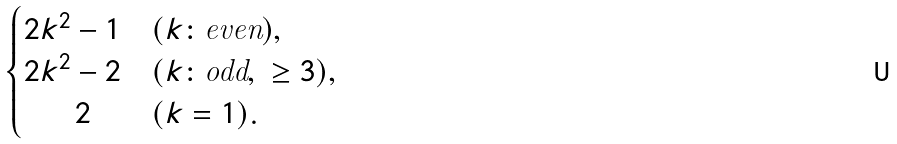<formula> <loc_0><loc_0><loc_500><loc_500>\begin{cases} 2 k ^ { 2 } - 1 & ( k \colon \text {even} ) , \\ 2 k ^ { 2 } - 2 & ( k \colon \text {odd} , \ \geq 3 ) , \\ \quad \ \ 2 & ( k = 1 ) . \end{cases}</formula> 